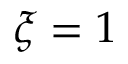Convert formula to latex. <formula><loc_0><loc_0><loc_500><loc_500>\xi = 1</formula> 